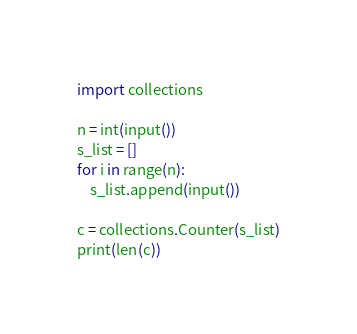Convert code to text. <code><loc_0><loc_0><loc_500><loc_500><_Python_>import collections

n = int(input())
s_list = []
for i in range(n):
    s_list.append(input())

c = collections.Counter(s_list)
print(len(c))</code> 